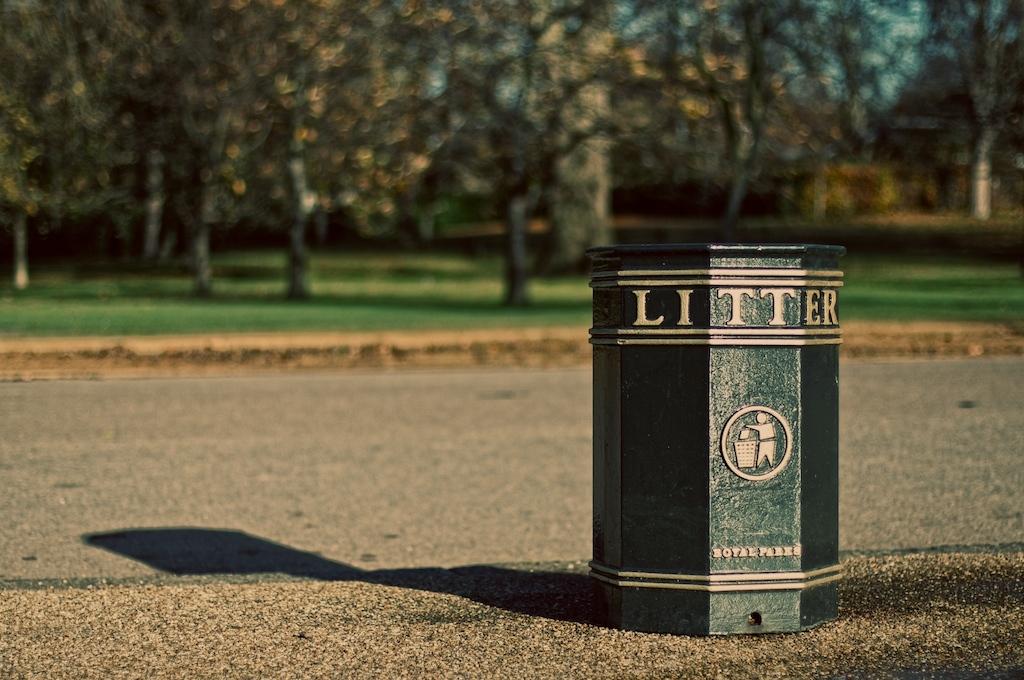What is on can?
Your answer should be compact. Litter. What is this bin for?
Offer a terse response. Litter. 